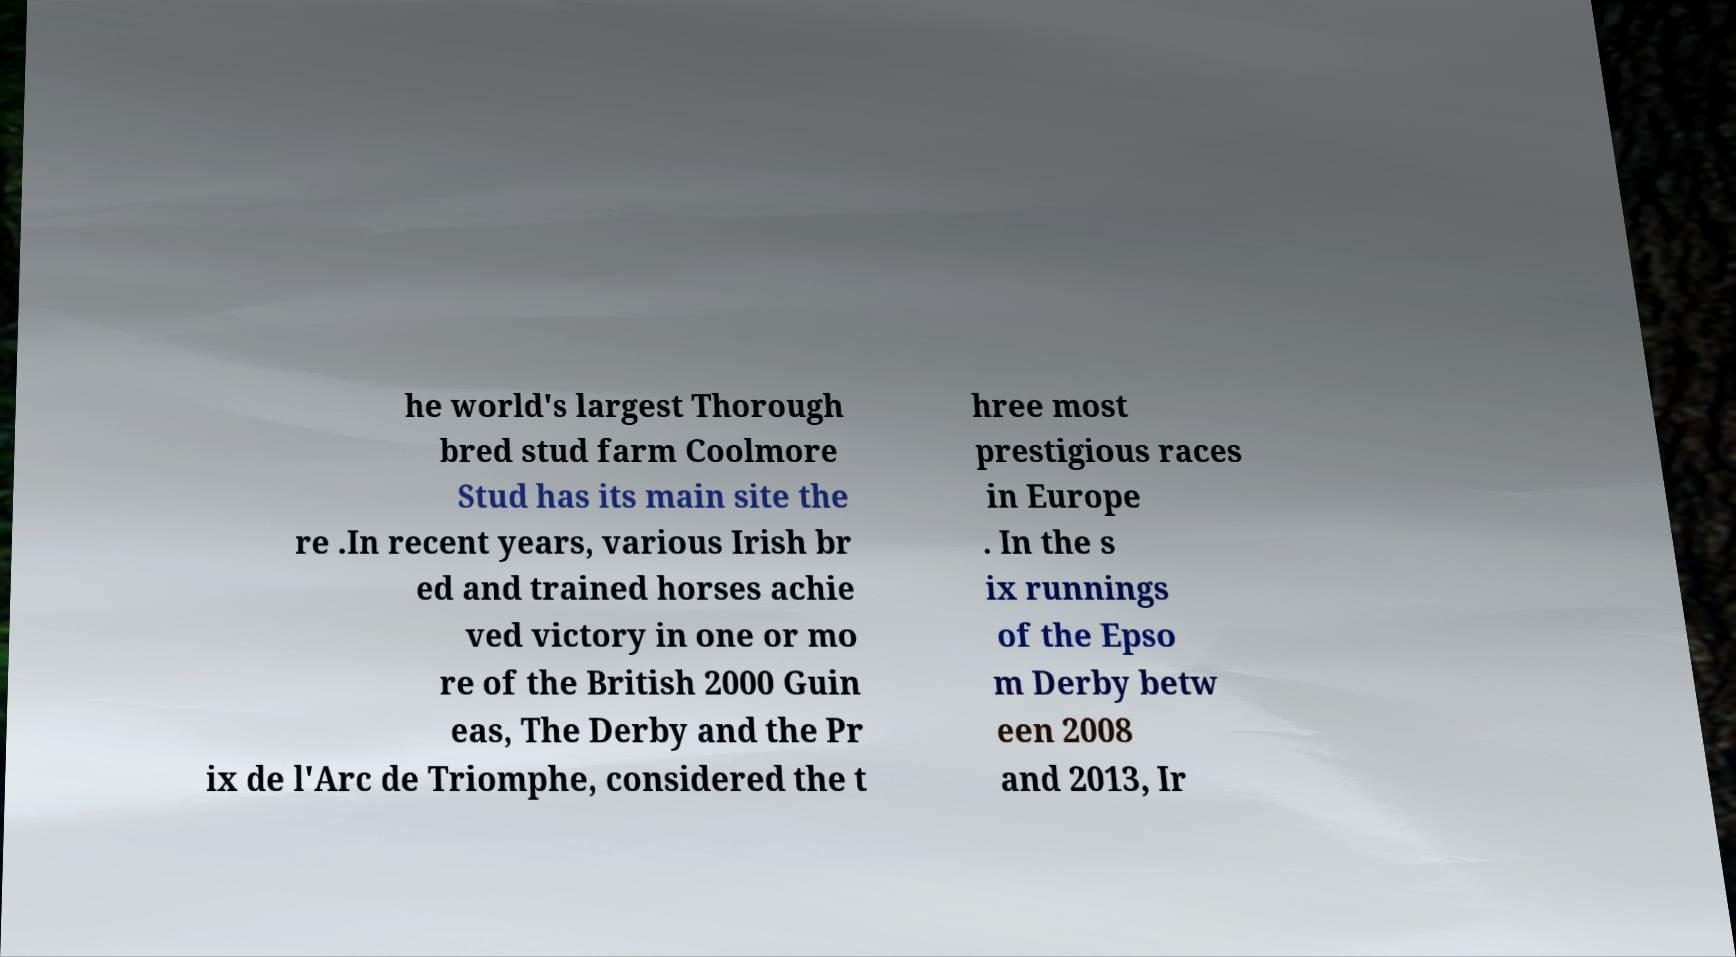Please identify and transcribe the text found in this image. he world's largest Thorough bred stud farm Coolmore Stud has its main site the re .In recent years, various Irish br ed and trained horses achie ved victory in one or mo re of the British 2000 Guin eas, The Derby and the Pr ix de l'Arc de Triomphe, considered the t hree most prestigious races in Europe . In the s ix runnings of the Epso m Derby betw een 2008 and 2013, Ir 